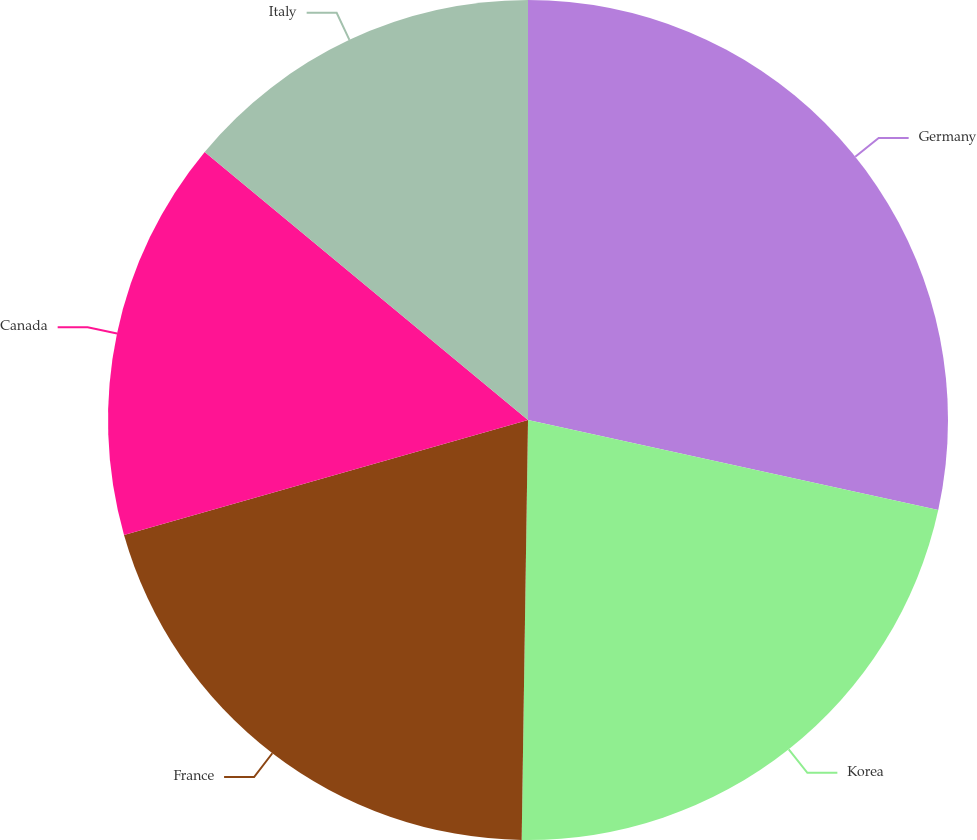Convert chart. <chart><loc_0><loc_0><loc_500><loc_500><pie_chart><fcel>Germany<fcel>Korea<fcel>France<fcel>Canada<fcel>Italy<nl><fcel>28.44%<fcel>21.8%<fcel>20.35%<fcel>15.43%<fcel>13.98%<nl></chart> 